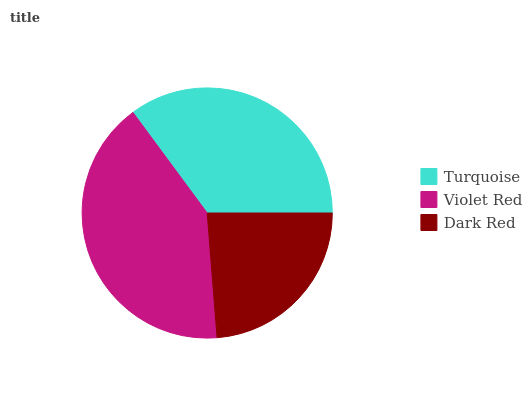Is Dark Red the minimum?
Answer yes or no. Yes. Is Violet Red the maximum?
Answer yes or no. Yes. Is Violet Red the minimum?
Answer yes or no. No. Is Dark Red the maximum?
Answer yes or no. No. Is Violet Red greater than Dark Red?
Answer yes or no. Yes. Is Dark Red less than Violet Red?
Answer yes or no. Yes. Is Dark Red greater than Violet Red?
Answer yes or no. No. Is Violet Red less than Dark Red?
Answer yes or no. No. Is Turquoise the high median?
Answer yes or no. Yes. Is Turquoise the low median?
Answer yes or no. Yes. Is Violet Red the high median?
Answer yes or no. No. Is Dark Red the low median?
Answer yes or no. No. 